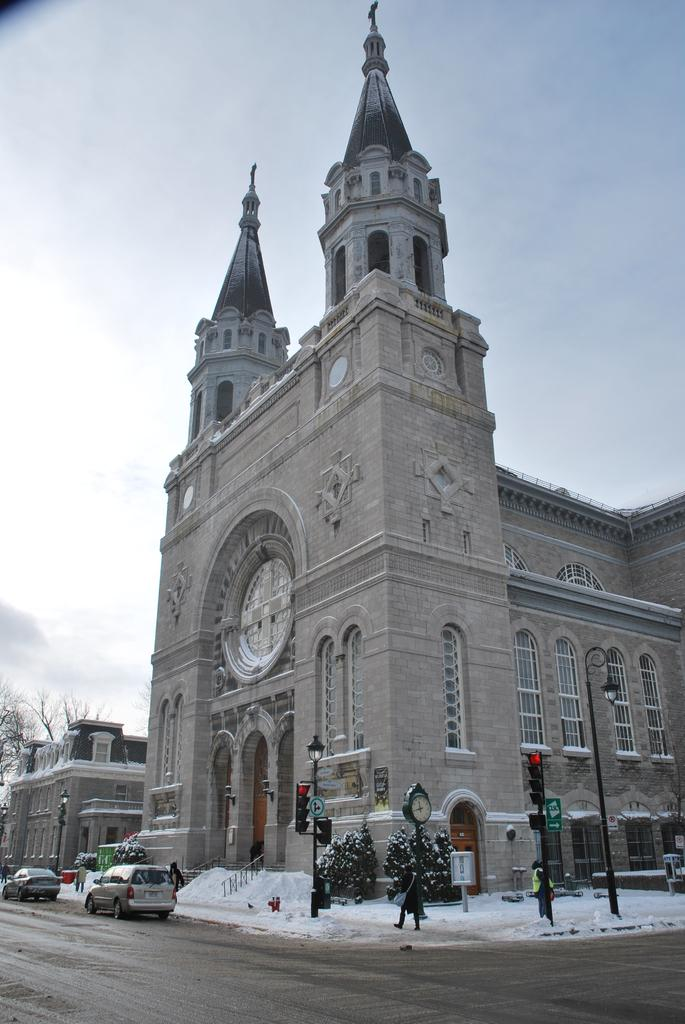What type of structures can be seen in the image? There are buildings in the image. What mode of transportation can be seen on the road? Motor vehicles are present on the road. What are the people in the image doing? There are people standing on the ground. What type of vertical structures can be seen in the image? Street poles are visible in the image. What type of lighting is present in the image? Street lights are present. What type of timekeeping device is visible in the image? There is a street clock in the image. What type of vegetation is present in the image? Plants and trees are visible in the image. What is visible in the sky in the image? The sky is visible with clouds. How many bears are visible in the image? There are no bears present in the image. What type of insect can be seen pulling the street clock in the image? There are no insects present in the image, and the street clock is not being pulled by any creature. 